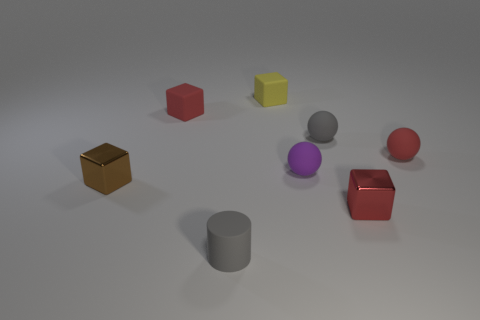Subtract 1 blocks. How many blocks are left? 3 Add 1 small purple matte balls. How many objects exist? 9 Subtract all spheres. How many objects are left? 5 Add 5 red matte balls. How many red matte balls are left? 6 Add 2 purple rubber spheres. How many purple rubber spheres exist? 3 Subtract 0 purple cylinders. How many objects are left? 8 Subtract all red blocks. Subtract all brown blocks. How many objects are left? 5 